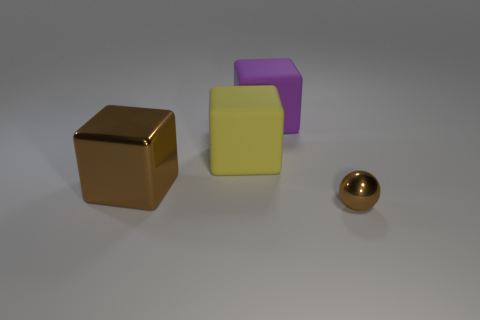Subtract all brown metal cubes. How many cubes are left? 2 Add 1 large yellow matte things. How many objects exist? 5 Subtract all purple cubes. How many cubes are left? 2 Add 1 large brown objects. How many large brown objects are left? 2 Add 1 big red balls. How many big red balls exist? 1 Subtract 0 cyan blocks. How many objects are left? 4 Subtract all spheres. How many objects are left? 3 Subtract all blue cubes. Subtract all purple cylinders. How many cubes are left? 3 Subtract all brown metallic objects. Subtract all metal balls. How many objects are left? 1 